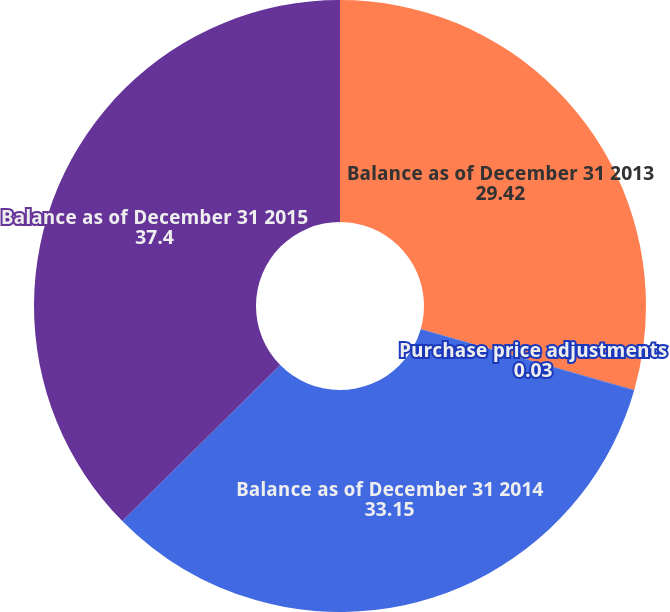Convert chart to OTSL. <chart><loc_0><loc_0><loc_500><loc_500><pie_chart><fcel>Balance as of December 31 2013<fcel>Purchase price adjustments<fcel>Balance as of December 31 2014<fcel>Balance as of December 31 2015<nl><fcel>29.42%<fcel>0.03%<fcel>33.15%<fcel>37.4%<nl></chart> 